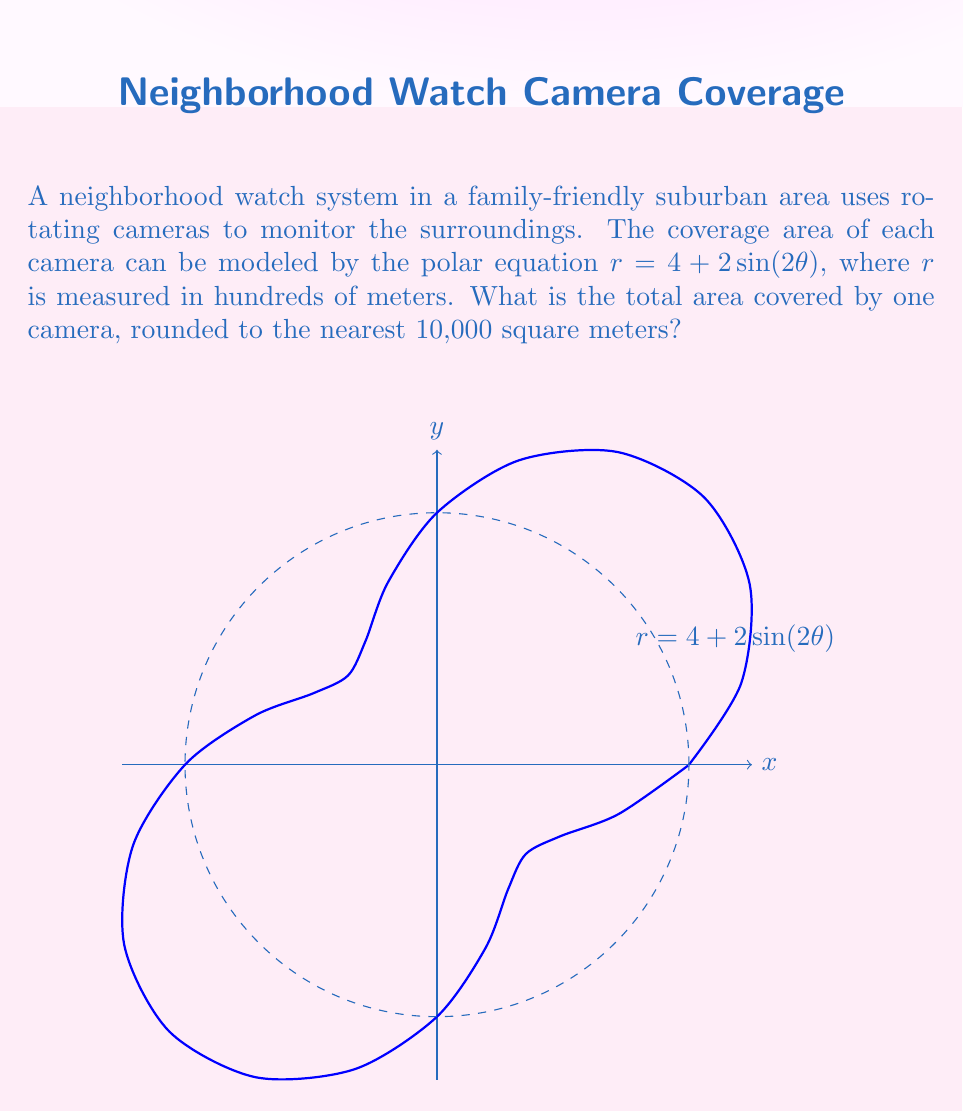Can you solve this math problem? To find the area covered by the camera, we need to use the formula for area in polar coordinates:

$$A = \frac{1}{2}\int_{0}^{2\pi} r^2 d\theta$$

1) Substitute the given equation $r = 4 + 2\sin(2\theta)$ into the formula:

   $$A = \frac{1}{2}\int_{0}^{2\pi} (4 + 2\sin(2\theta))^2 d\theta$$

2) Expand the squared term:

   $$A = \frac{1}{2}\int_{0}^{2\pi} (16 + 16\sin(2\theta) + 4\sin^2(2\theta)) d\theta$$

3) Integrate each term:

   $$A = \frac{1}{2}[16\theta - 8\cos(2\theta) + \theta - \frac{1}{4}\sin(4\theta)]_{0}^{2\pi}$$

4) Evaluate the integral:

   $$A = \frac{1}{2}[(16\cdot2\pi + 2\pi) - (0 + 0)] = 17\pi$$

5) Remember that $r$ was measured in hundreds of meters, so we need to multiply by $100^2 = 10000$ to get the area in square meters:

   $$A = 17\pi \cdot 10000 \approx 534071.8 \text{ square meters}$$

6) Rounding to the nearest 10,000 square meters:

   $$A \approx 530000 \text{ square meters}$$
Answer: 530,000 square meters 